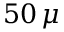Convert formula to latex. <formula><loc_0><loc_0><loc_500><loc_500>5 0 \, \mu</formula> 